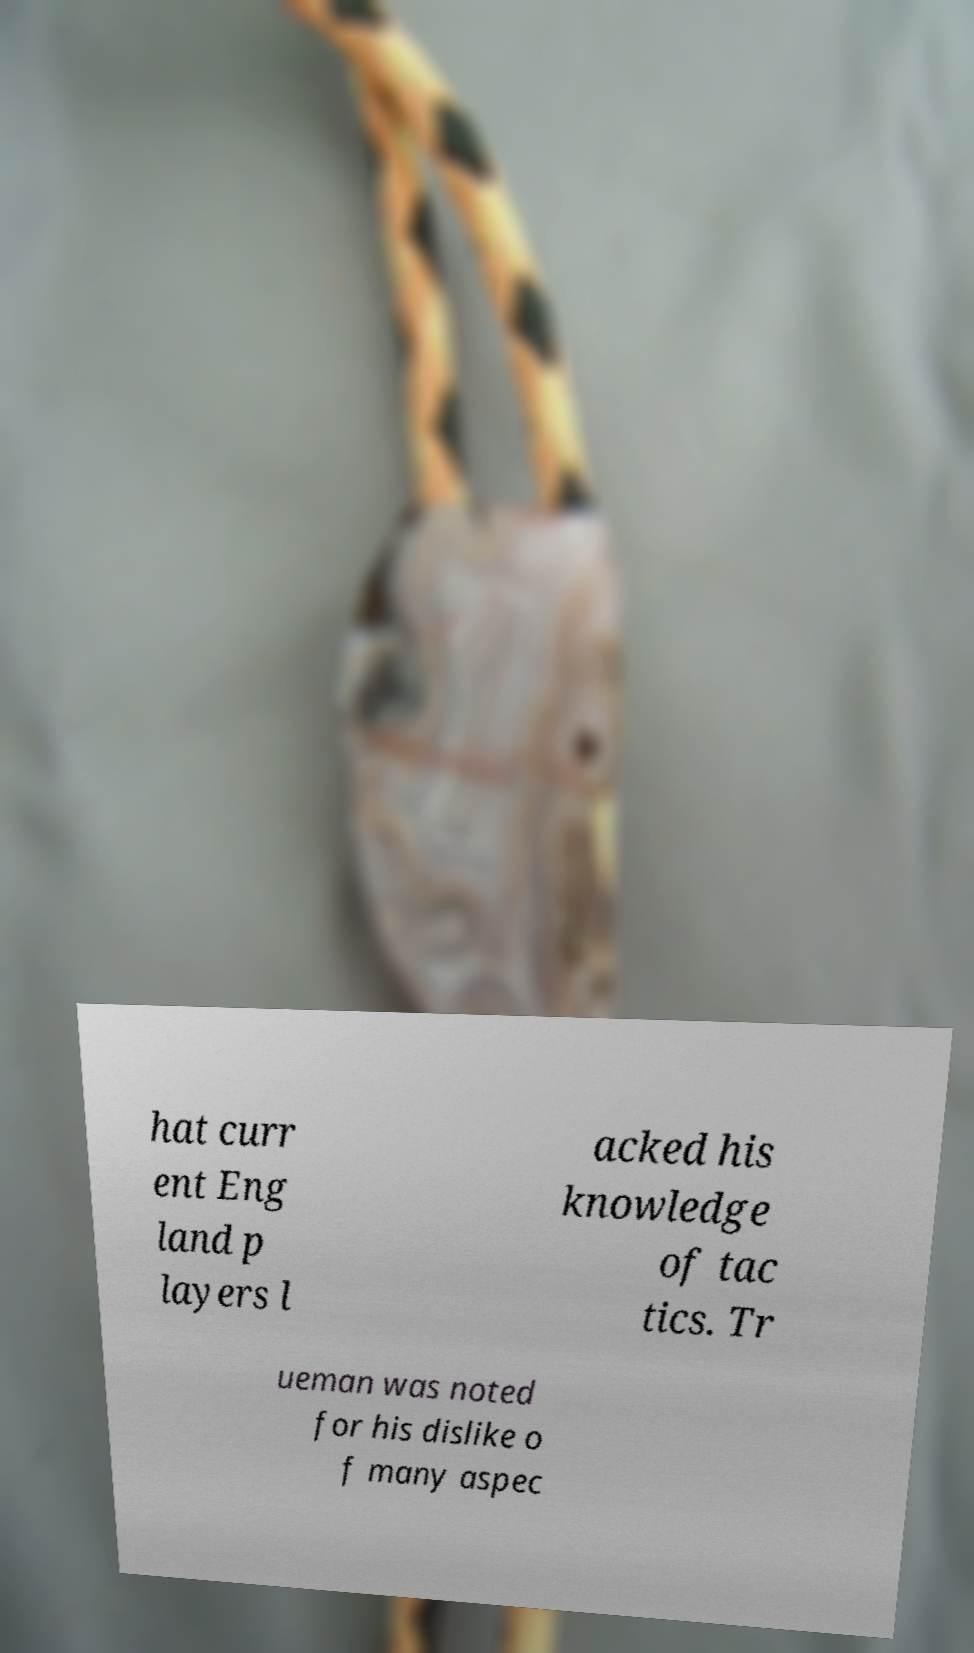What messages or text are displayed in this image? I need them in a readable, typed format. hat curr ent Eng land p layers l acked his knowledge of tac tics. Tr ueman was noted for his dislike o f many aspec 